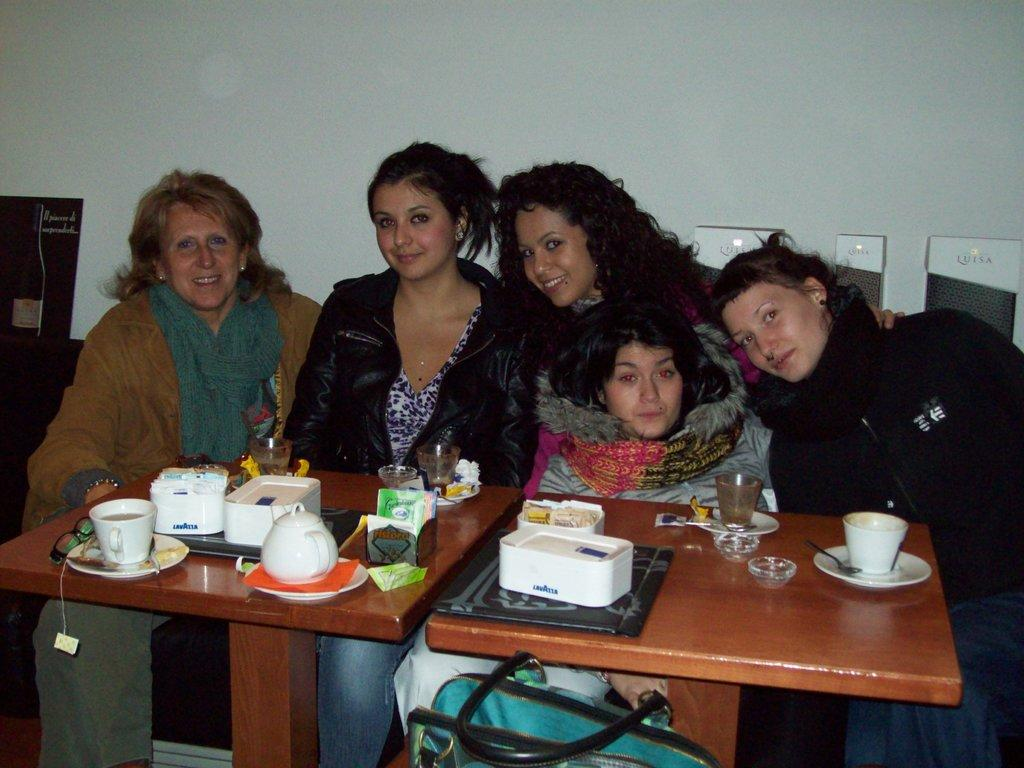How many ladies are present in the image? There are five ladies in the image. What is the facial expression of the ladies? The ladies are smiling. What is located in front of the ladies? There is a table in front of the ladies. What items can be seen on the table? There are coffee cups and kettles on the table. What account number is written on the kettle in the image? There is no account number written on the kettle in the image; kettles are not typically associated with account numbers. 